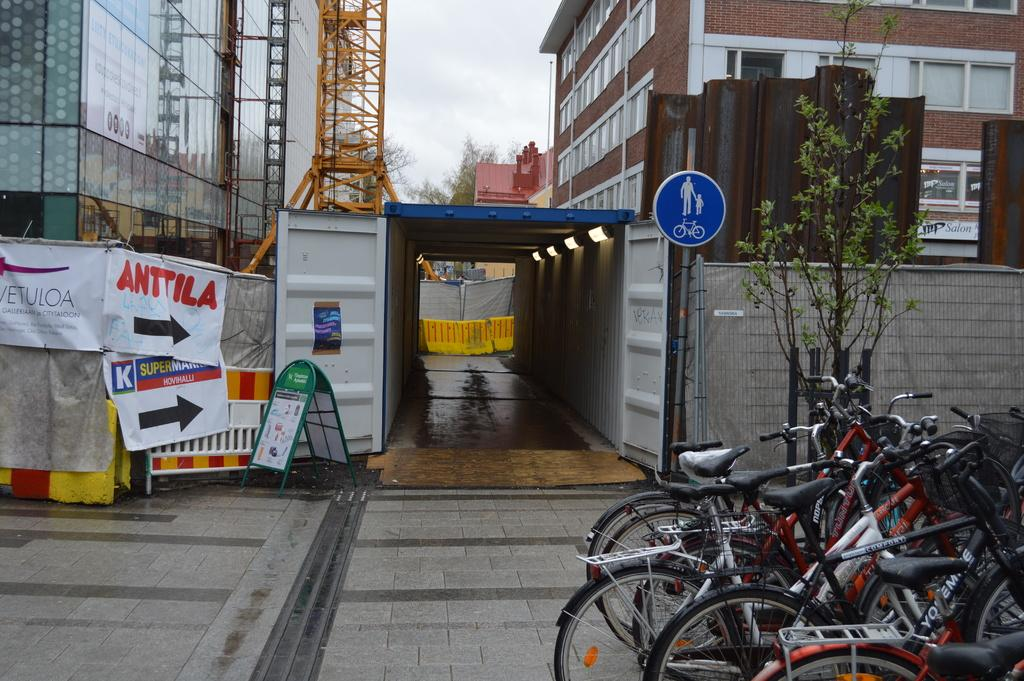What type of structures can be seen in the image? There are buildings in the image. What objects are used for cooking in the image? There are grills in the image. What type of signs are present in the image? There are sign boards and advertising boards in the image. What mode of transportation can be seen in the image? There are bicycles in the image. What type of vegetation is present in the image? There are plants in the image. What part of the natural environment is visible in the image? The sky is visible in the image. What type of riddle can be seen on the advertising board in the image? There is no riddle present on the advertising board in the image. Can you tell me how many bears are visible in the image? There are no bears present in the image. 